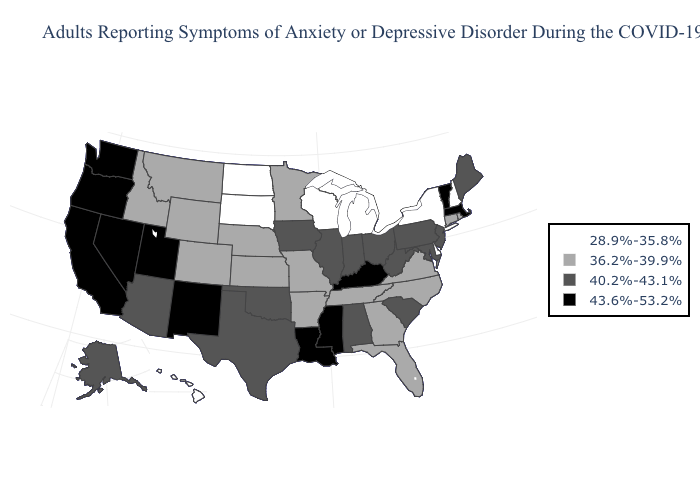Name the states that have a value in the range 28.9%-35.8%?
Short answer required. Delaware, Hawaii, Michigan, New Hampshire, New York, North Dakota, South Dakota, Wisconsin. Name the states that have a value in the range 43.6%-53.2%?
Answer briefly. California, Kentucky, Louisiana, Massachusetts, Mississippi, Nevada, New Mexico, Oregon, Utah, Vermont, Washington. Name the states that have a value in the range 43.6%-53.2%?
Keep it brief. California, Kentucky, Louisiana, Massachusetts, Mississippi, Nevada, New Mexico, Oregon, Utah, Vermont, Washington. Does Montana have a higher value than New Jersey?
Answer briefly. No. What is the value of Louisiana?
Short answer required. 43.6%-53.2%. Name the states that have a value in the range 28.9%-35.8%?
Quick response, please. Delaware, Hawaii, Michigan, New Hampshire, New York, North Dakota, South Dakota, Wisconsin. What is the value of Nevada?
Concise answer only. 43.6%-53.2%. Does the map have missing data?
Be succinct. No. What is the value of Idaho?
Write a very short answer. 36.2%-39.9%. Name the states that have a value in the range 43.6%-53.2%?
Keep it brief. California, Kentucky, Louisiana, Massachusetts, Mississippi, Nevada, New Mexico, Oregon, Utah, Vermont, Washington. Among the states that border Connecticut , which have the lowest value?
Be succinct. New York. What is the value of Pennsylvania?
Answer briefly. 40.2%-43.1%. Does Washington have the highest value in the West?
Quick response, please. Yes. How many symbols are there in the legend?
Write a very short answer. 4. Does the first symbol in the legend represent the smallest category?
Keep it brief. Yes. 